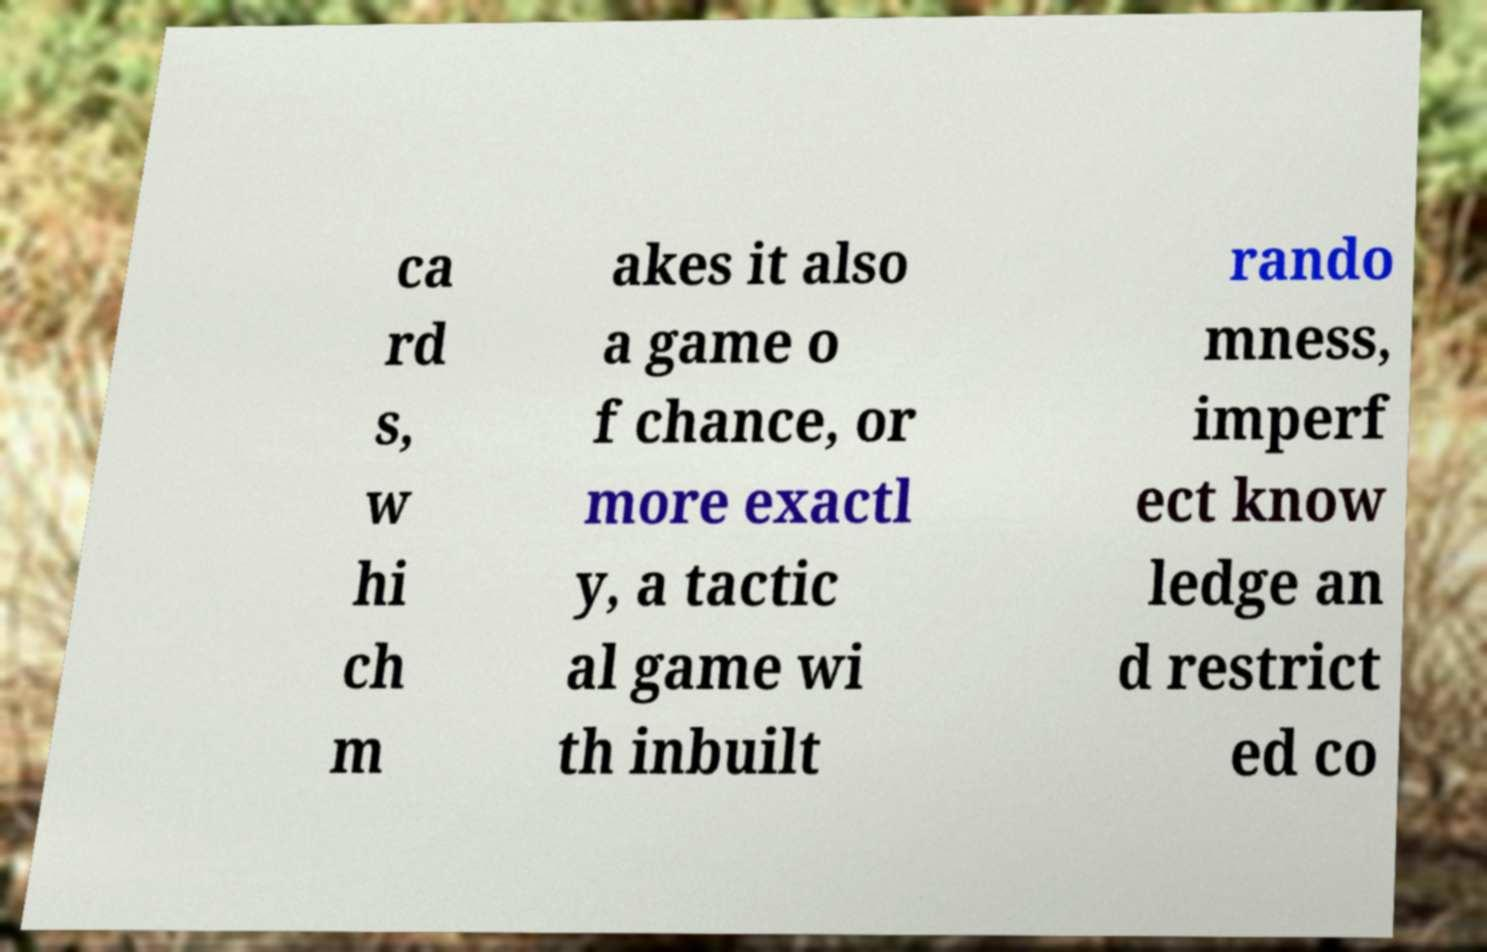Please read and relay the text visible in this image. What does it say? ca rd s, w hi ch m akes it also a game o f chance, or more exactl y, a tactic al game wi th inbuilt rando mness, imperf ect know ledge an d restrict ed co 